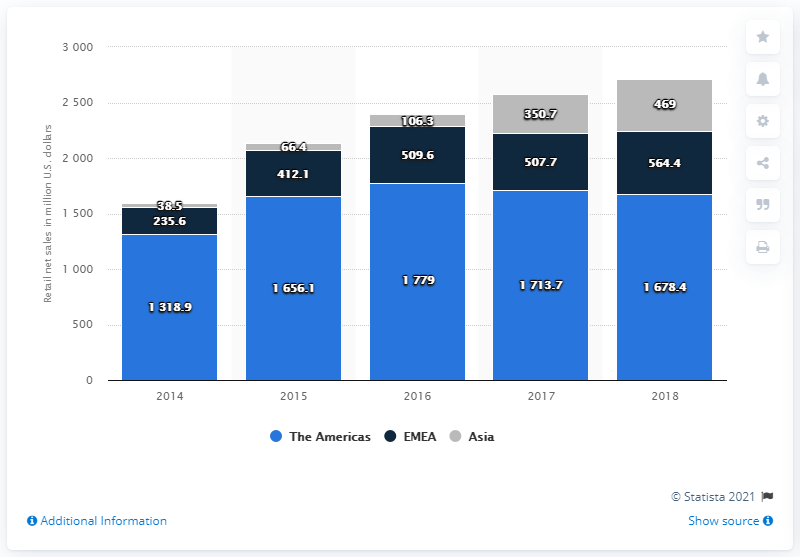Specify some key components in this picture. In 2018, the retail net sales generated by Michael Kors in the EMEA (Europe, Middle East, and Africa) region was 564.4 million dollars. 